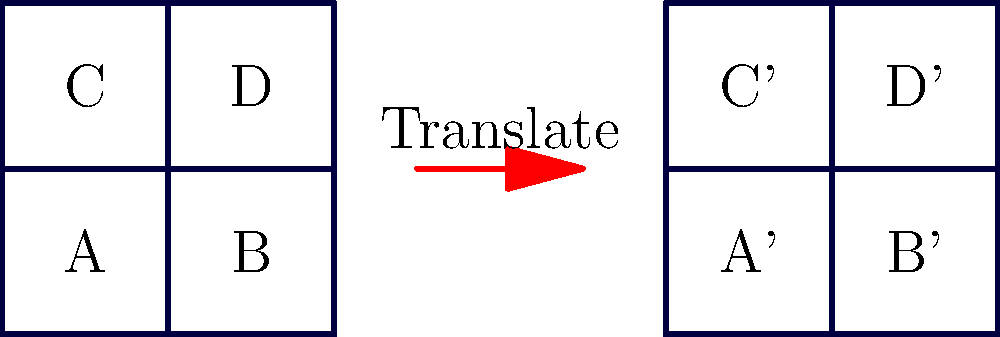In preparation for upcoming local elections, you're working on a project to analyze voting district maps. The image shows a simplified map of four voting districts (A, B, C, and D) before and after a translation. If the map is translated 8 units to the right, what are the coordinates of the center of district D after the translation? To solve this problem, we need to follow these steps:

1. Identify the original coordinates of the center of district D:
   - The center of district D is at point (3,3) in the original map.

2. Understand the translation:
   - The map is translated 8 units to the right.
   - This means we add 8 to the x-coordinate and leave the y-coordinate unchanged.

3. Apply the translation to the coordinates of the center of district D:
   - Original coordinates: (3,3)
   - Translation: 8 units right
   - New x-coordinate: $3 + 8 = 11$
   - New y-coordinate: 3 (unchanged)

4. Express the new coordinates:
   - After translation, the center of district D (now labeled D') is at (11,3).

The translation can be represented mathematically as:
$$(x, y) \rightarrow (x + 8, y)$$

For the center of district D:
$$(3, 3) \rightarrow (3 + 8, 3) = (11, 3)$$
Answer: (11,3) 